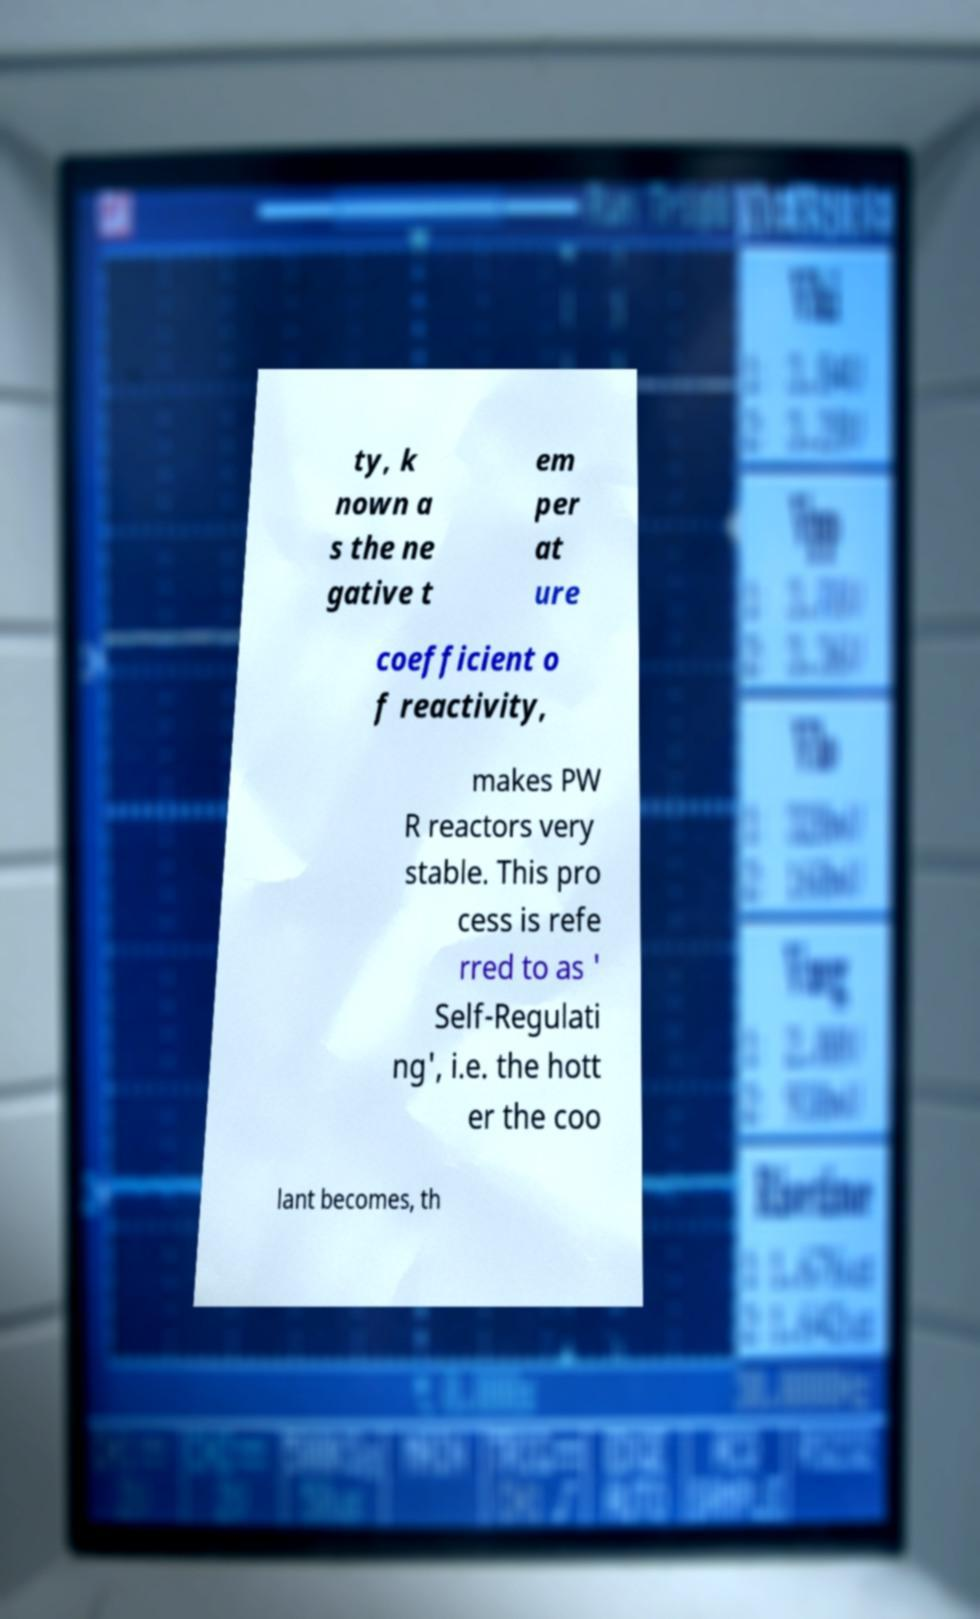I need the written content from this picture converted into text. Can you do that? ty, k nown a s the ne gative t em per at ure coefficient o f reactivity, makes PW R reactors very stable. This pro cess is refe rred to as ' Self-Regulati ng', i.e. the hott er the coo lant becomes, th 